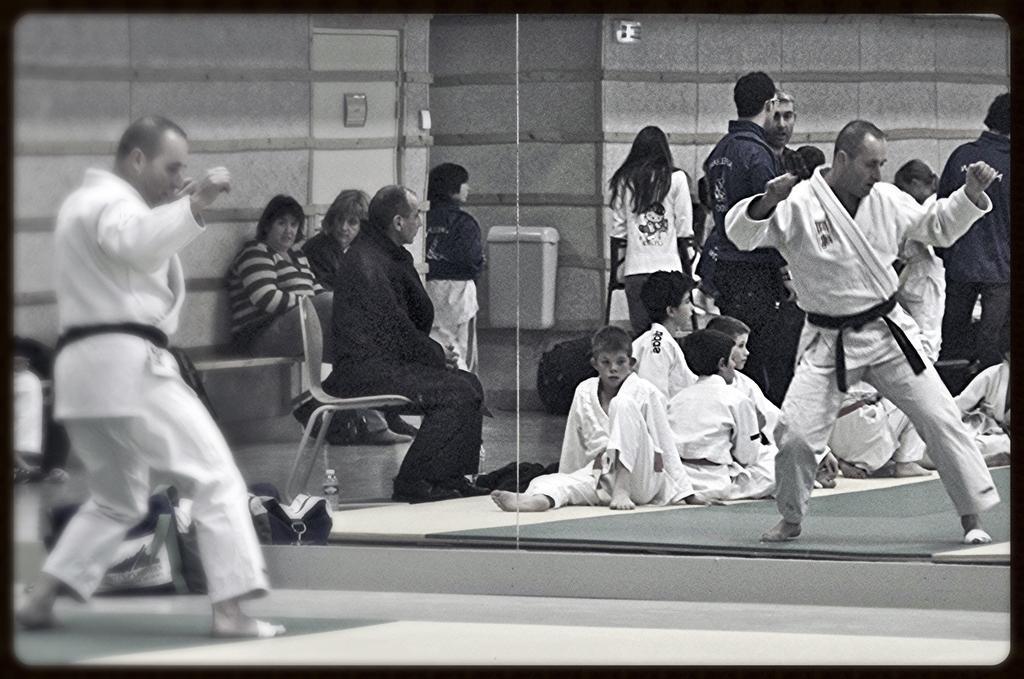In one or two sentences, can you explain what this image depicts? In this image I can see the person wearing the dress. In-front of the dress I can see the mirror. In the mirror I can see the reflection of many people. I can see few are sitting on the floor, few people are on the chair and few are standing. In the background I can see a box attached to the wall. 